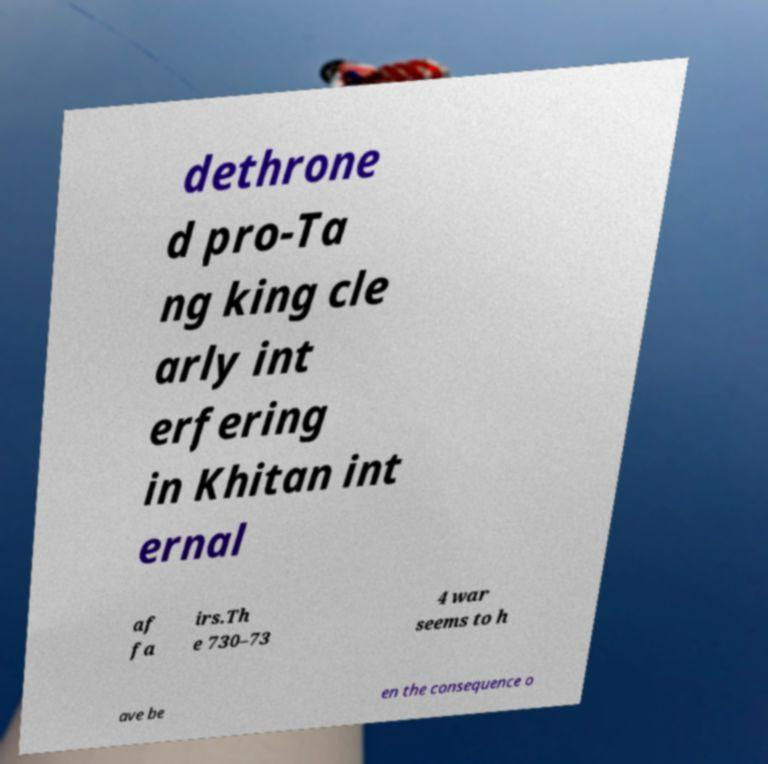What messages or text are displayed in this image? I need them in a readable, typed format. dethrone d pro-Ta ng king cle arly int erfering in Khitan int ernal af fa irs.Th e 730–73 4 war seems to h ave be en the consequence o 